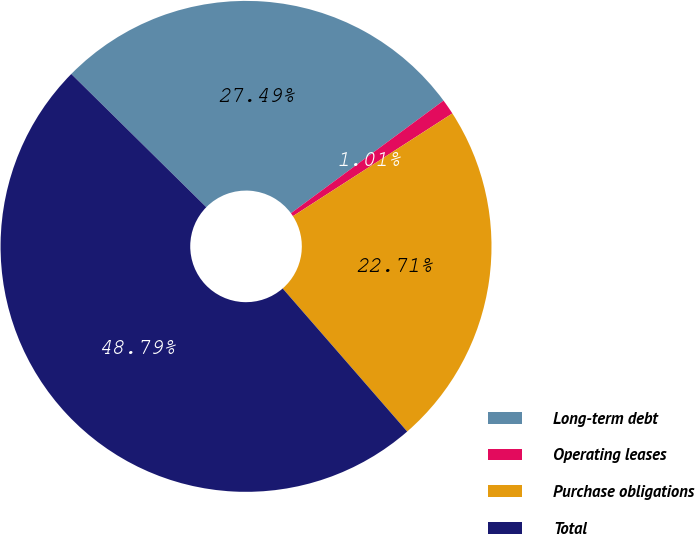Convert chart to OTSL. <chart><loc_0><loc_0><loc_500><loc_500><pie_chart><fcel>Long-term debt<fcel>Operating leases<fcel>Purchase obligations<fcel>Total<nl><fcel>27.49%<fcel>1.01%<fcel>22.71%<fcel>48.79%<nl></chart> 